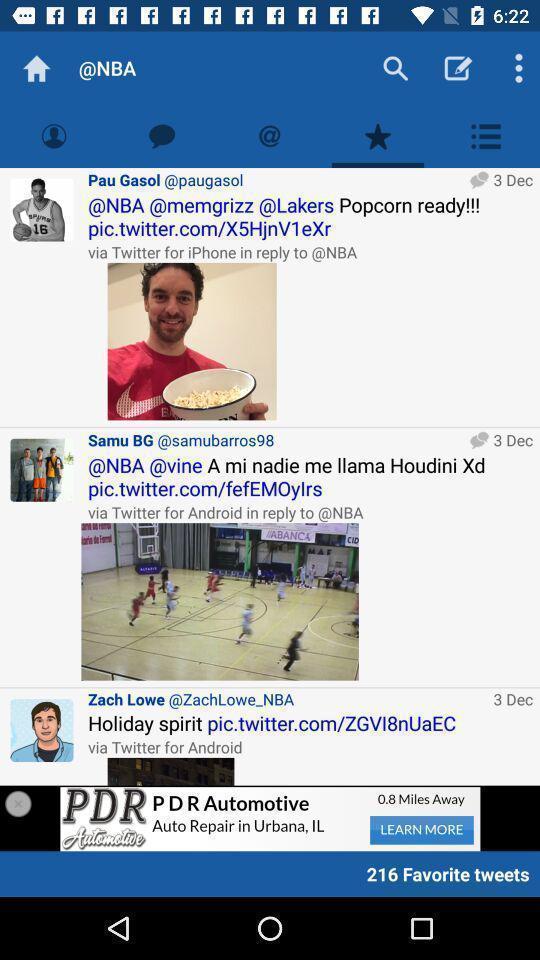Tell me about the visual elements in this screen capture. Page showing the posts. 